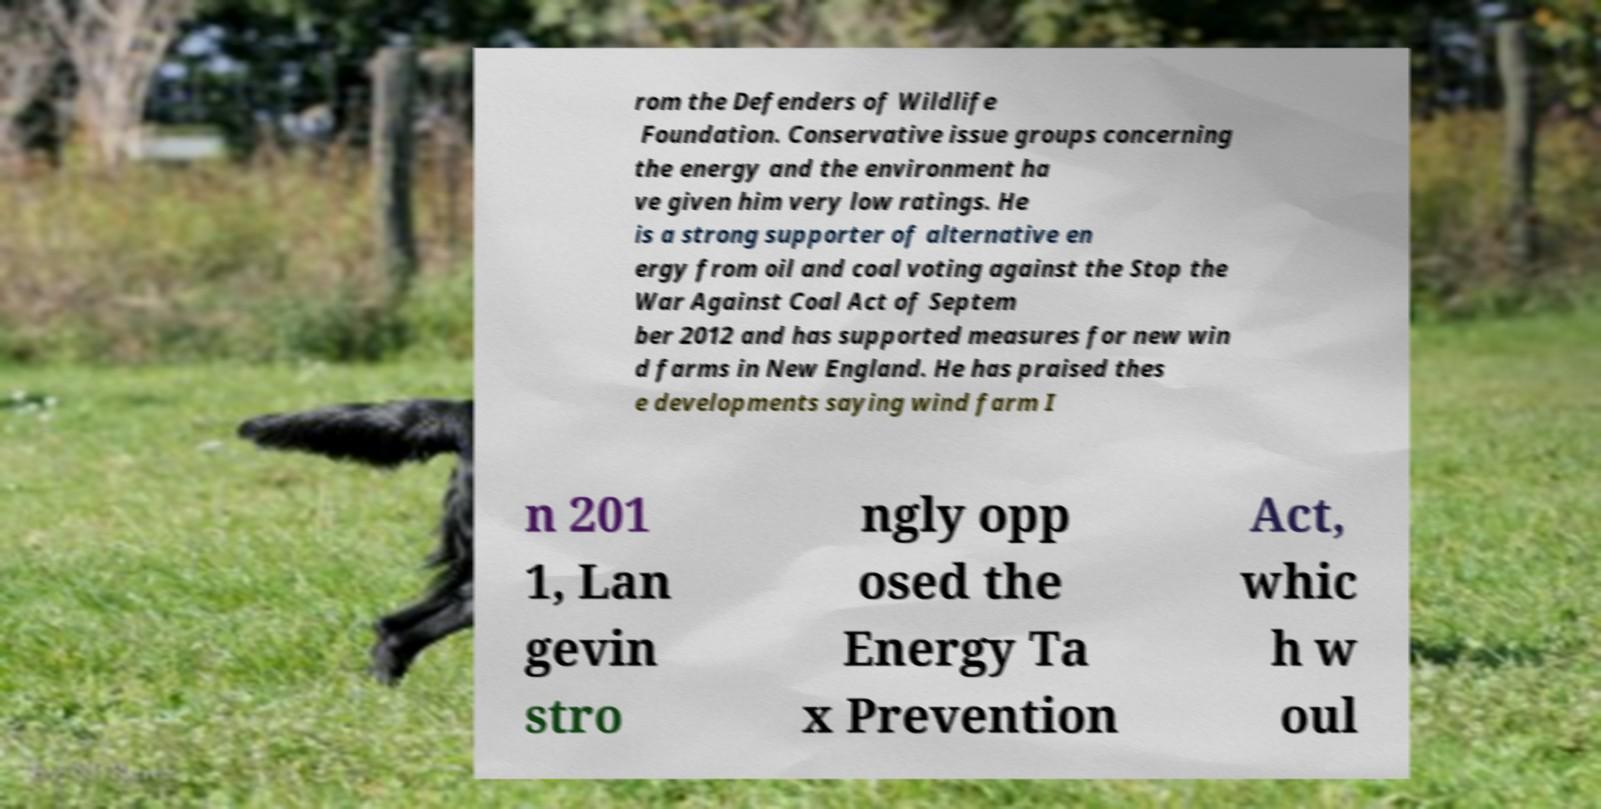Can you accurately transcribe the text from the provided image for me? rom the Defenders of Wildlife Foundation. Conservative issue groups concerning the energy and the environment ha ve given him very low ratings. He is a strong supporter of alternative en ergy from oil and coal voting against the Stop the War Against Coal Act of Septem ber 2012 and has supported measures for new win d farms in New England. He has praised thes e developments saying wind farm I n 201 1, Lan gevin stro ngly opp osed the Energy Ta x Prevention Act, whic h w oul 